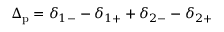<formula> <loc_0><loc_0><loc_500><loc_500>\Delta _ { p } = \delta _ { 1 - } - \delta _ { 1 + } + \delta _ { 2 - } - \delta _ { 2 + }</formula> 